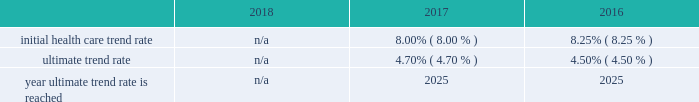Marathon oil corporation notes to consolidated financial statements expected long-term return on plan assets 2013 the expected long-term return on plan assets assumption for our u.s .
Funded plan is determined based on an asset rate-of-return modeling tool developed by a third-party investment group which utilizes underlying assumptions based on actual returns by asset category and inflation and takes into account our u.s .
Pension plan 2019s asset allocation .
To determine the expected long-term return on plan assets assumption for our international plans , we consider the current level of expected returns on risk-free investments ( primarily government bonds ) , the historical levels of the risk premiums associated with the other applicable asset categories and the expectations for future returns of each asset class .
The expected return for each asset category is then weighted based on the actual asset allocation to develop the overall expected long-term return on plan assets assumption .
Assumed weighted average health care cost trend rates .
N/a all retiree medical subsidies are frozen as of january 1 , 2019 .
Employer provided subsidies for post-65 retiree health care coverage were frozen effective january 1 , 2017 at january 1 , 2016 established amount levels .
Company contributions are funded to a health reimbursement account on the retiree 2019s behalf to subsidize the retiree 2019s cost of obtaining health care benefits through a private exchange ( the 201cpost-65 retiree health benefits 201d ) .
Therefore , a 1% ( 1 % ) change in health care cost trend rates would not have a material impact on either the service and interest cost components and the postretirement benefit obligations .
In the fourth quarter of 2018 , we terminated the post-65 retiree health benefits effective as of december 31 , 2020 .
The post-65 retiree health benefits will no longer be provided after that date .
In addition , the pre-65 retiree medical coverage subsidy has been frozen as of january 1 , 2019 , and the ability for retirees to opt in and out of this coverage , as well as pre-65 retiree dental and vision coverage , has also been eliminated .
Retirees must enroll in connection with retirement for such coverage , or they lose eligibility .
These plan changes reduced our retiree medical benefit obligation by approximately $ 99 million .
Plan investment policies and strategies 2013 the investment policies for our u.s .
And international pension plan assets reflect the funded status of the plans and expectations regarding our future ability to make further contributions .
Long-term investment goals are to : ( 1 ) manage the assets in accordance with applicable legal requirements ; ( 2 ) produce investment returns which meet or exceed the rates of return achievable in the capital markets while maintaining the risk parameters set by the plan's investment committees and protecting the assets from any erosion of purchasing power ; and ( 3 ) position the portfolios with a long-term risk/ return orientation .
Investment performance and risk is measured and monitored on an ongoing basis through quarterly investment meetings and periodic asset and liability studies .
U.s .
Plan 2013 the plan 2019s current targeted asset allocation is comprised of 55% ( 55 % ) equity securities and 45% ( 45 % ) other fixed income securities .
Over time , as the plan 2019s funded ratio ( as defined by the investment policy ) improves , in order to reduce volatility in returns and to better match the plan 2019s liabilities , the allocation to equity securities will decrease while the amount allocated to fixed income securities will increase .
The plan's assets are managed by a third-party investment manager .
International plan 2013 our international plan's target asset allocation is comprised of 55% ( 55 % ) equity securities and 45% ( 45 % ) fixed income securities .
The plan assets are invested in ten separate portfolios , mainly pooled fund vehicles , managed by several professional investment managers whose performance is measured independently by a third-party asset servicing consulting fair value measurements 2013 plan assets are measured at fair value .
The following provides a description of the valuation techniques employed for each major plan asset class at december 31 , 2018 and 2017 .
Cash and cash equivalents 2013 cash and cash equivalents are valued using a market approach and are considered level 1 .
Equity securities 2013 investments in common stock are valued using a market approach at the closing price reported in an active market and are therefore considered level 1 .
Private equity investments include interests in limited partnerships which are valued based on the sum of the estimated fair values of the investments held by each partnership , determined using a combination of market , income and cost approaches , plus working capital , adjusted for liabilities , currency translation and estimated performance incentives .
These private equity investments are considered level 3 .
Investments in pooled funds are valued using a market approach , these various funds consist of equity with underlying investments held in u.s .
And non-u.s .
Securities .
The pooled funds are benchmarked against a relative public index and are considered level 2. .
Was initial health care trend rate higher in 2017 than 2016? 
Computations: (8.00 > 8.25)
Answer: no. 